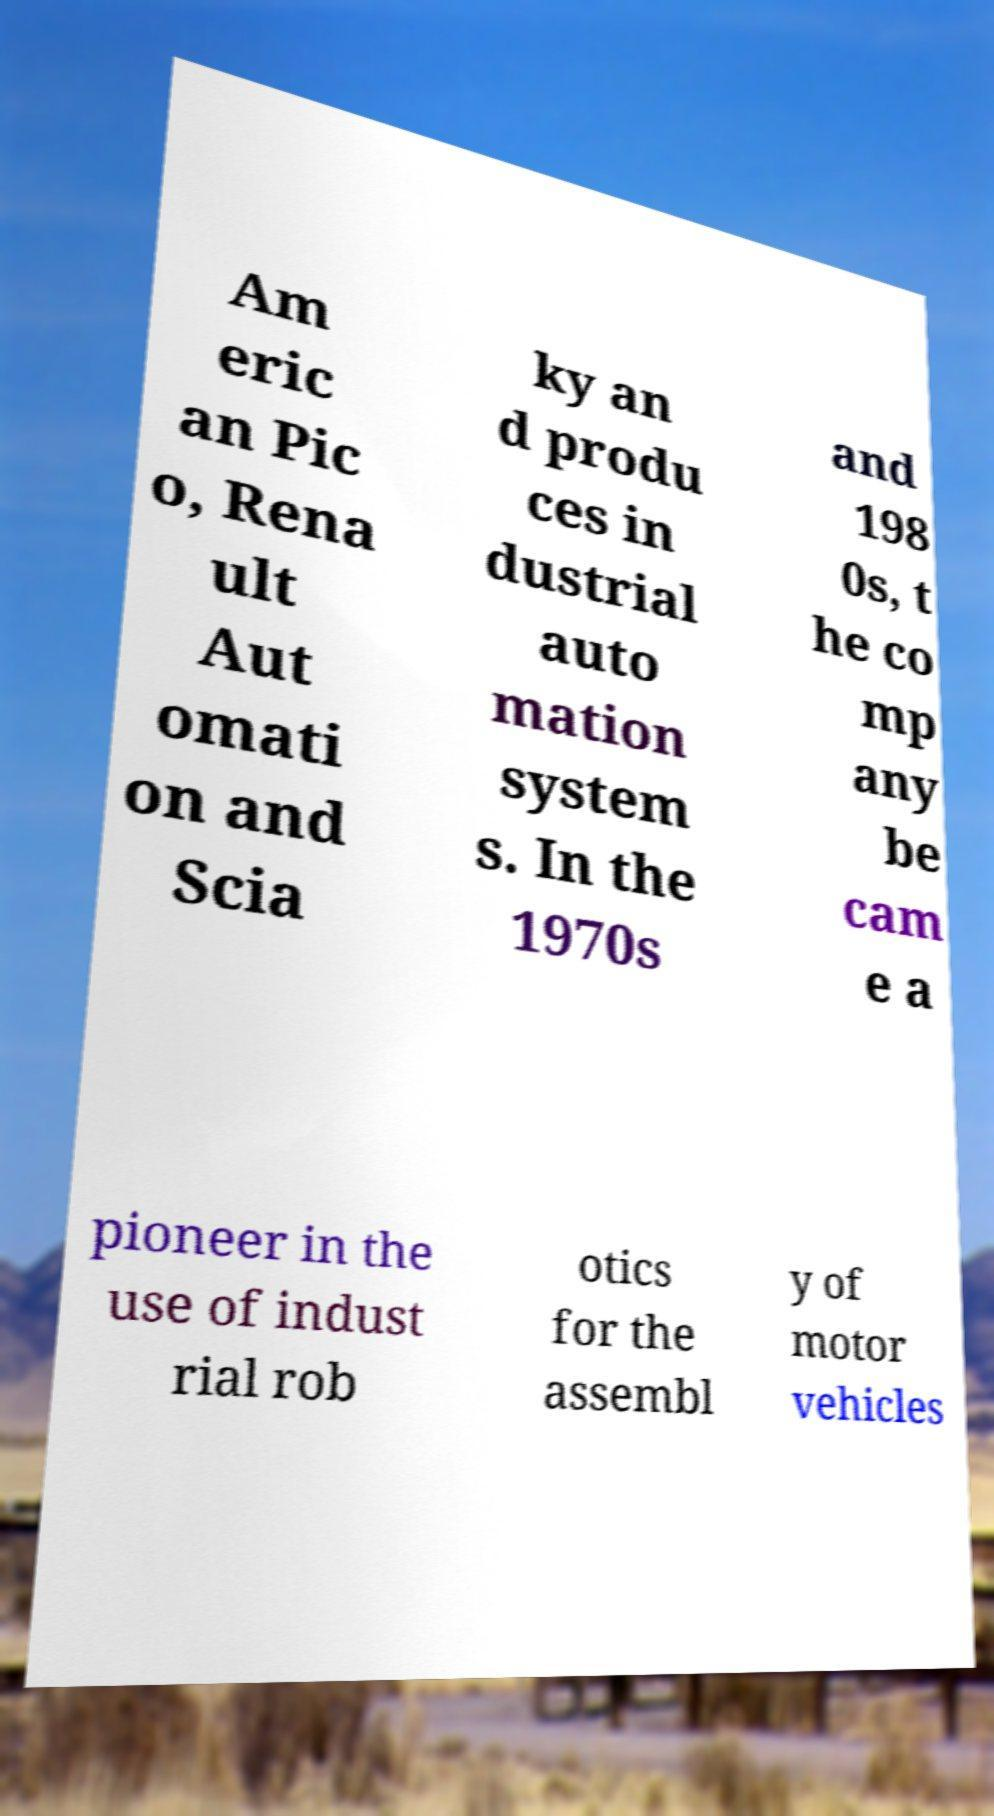Can you read and provide the text displayed in the image?This photo seems to have some interesting text. Can you extract and type it out for me? Am eric an Pic o, Rena ult Aut omati on and Scia ky an d produ ces in dustrial auto mation system s. In the 1970s and 198 0s, t he co mp any be cam e a pioneer in the use of indust rial rob otics for the assembl y of motor vehicles 